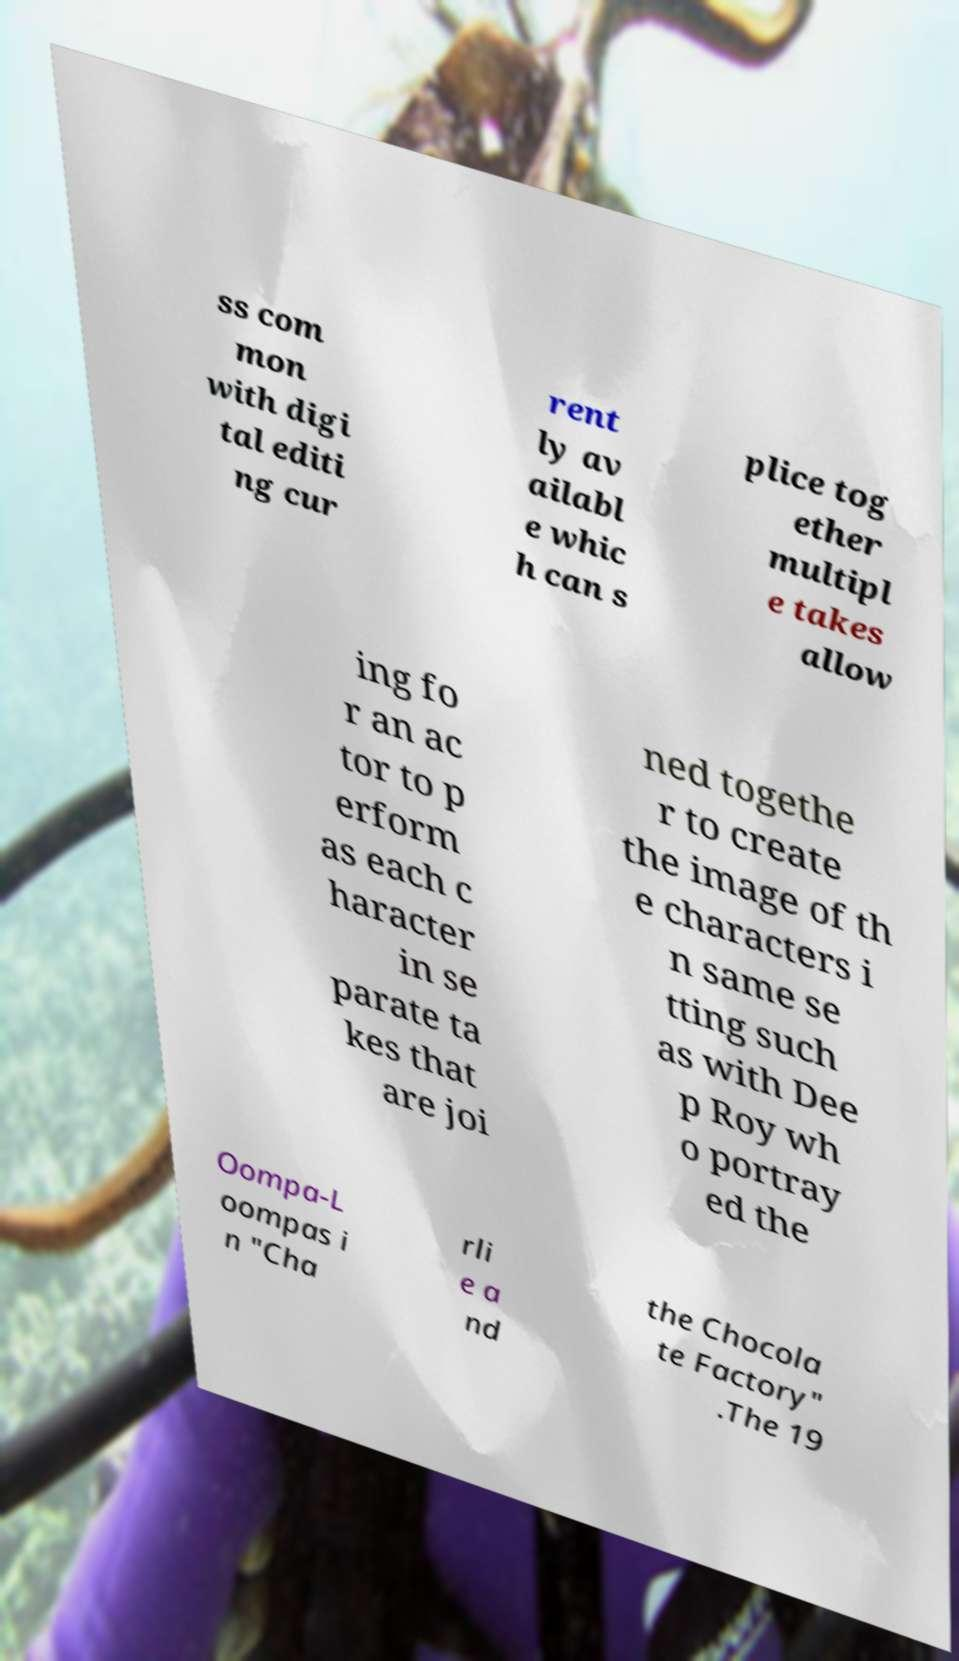Can you accurately transcribe the text from the provided image for me? ss com mon with digi tal editi ng cur rent ly av ailabl e whic h can s plice tog ether multipl e takes allow ing fo r an ac tor to p erform as each c haracter in se parate ta kes that are joi ned togethe r to create the image of th e characters i n same se tting such as with Dee p Roy wh o portray ed the Oompa-L oompas i n "Cha rli e a nd the Chocola te Factory" .The 19 